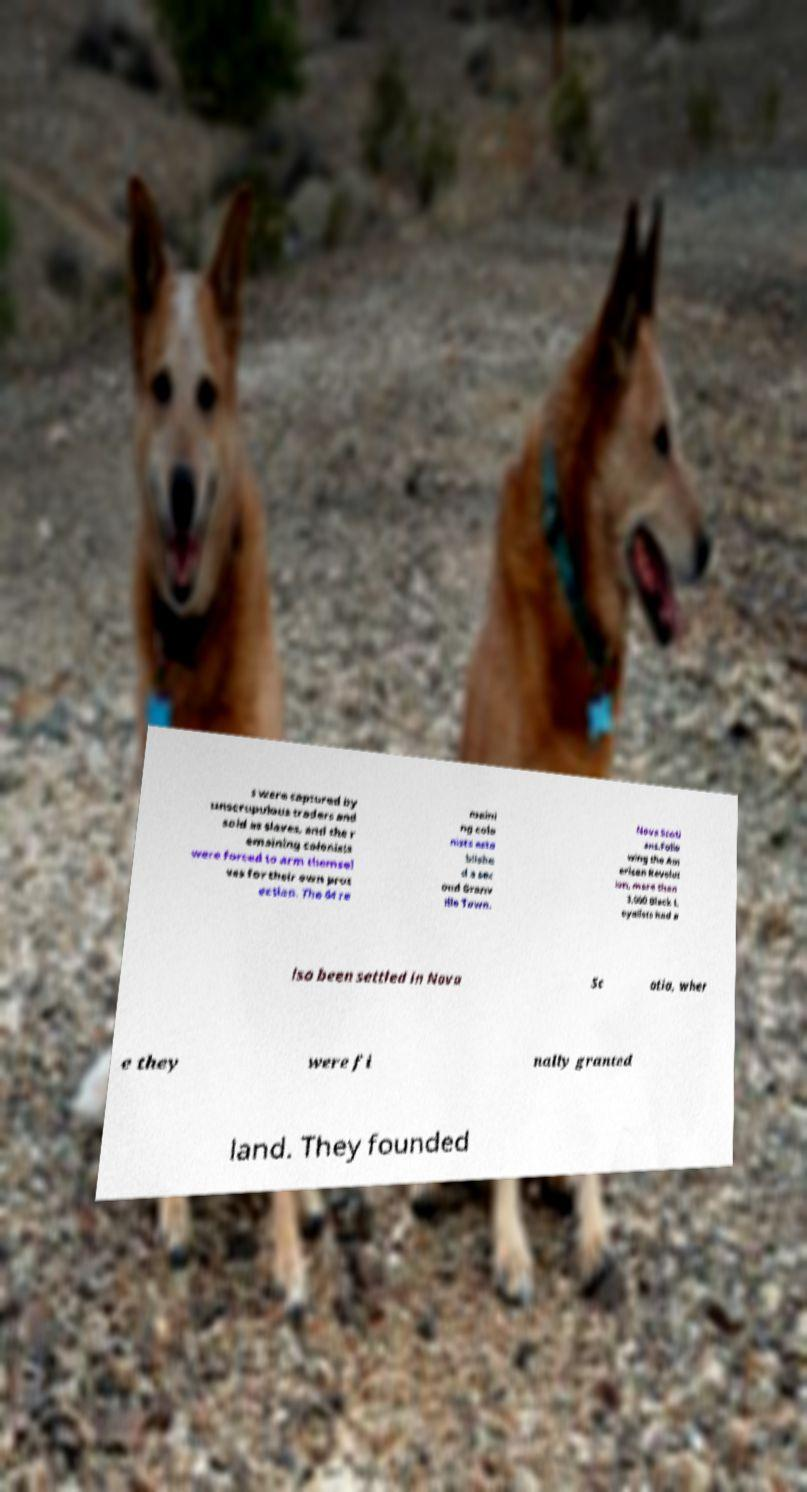Could you extract and type out the text from this image? s were captured by unscrupulous traders and sold as slaves, and the r emaining colonists were forced to arm themsel ves for their own prot ection. The 64 re maini ng colo nists esta blishe d a sec ond Granv ille Town. Nova Scoti ans.Follo wing the Am erican Revolut ion, more than 3,000 Black L oyalists had a lso been settled in Nova Sc otia, wher e they were fi nally granted land. They founded 